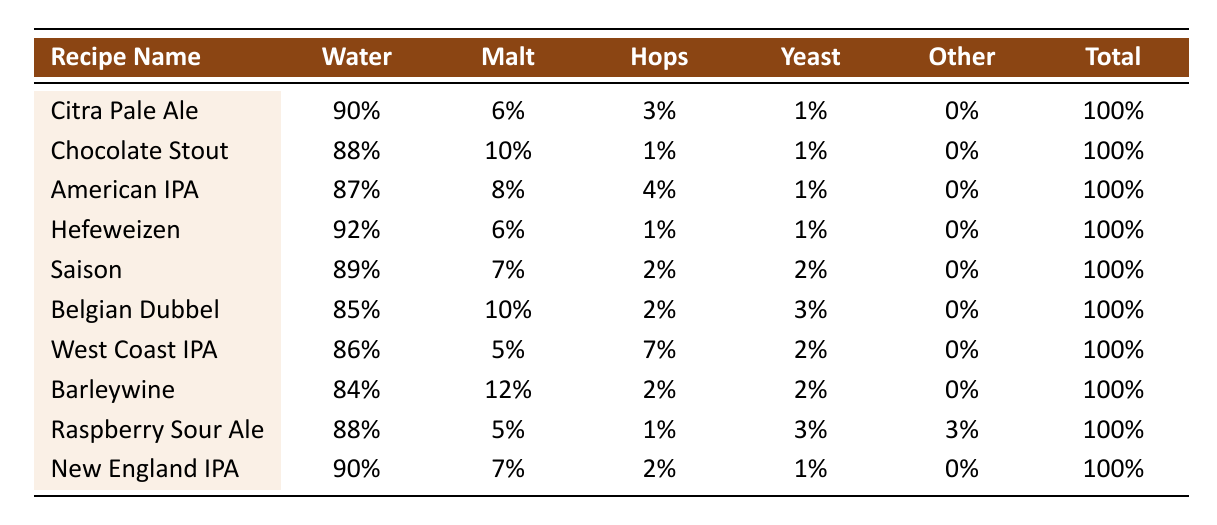What is the water percentage in the "Belgian Dubbel" recipe? The table shows that the water percentage in the "Belgian Dubbel" recipe is 85%
Answer: 85% Which recipe has the highest hops percentage? By reviewing the table, the "West Coast IPA" has the highest hops percentage at 7%.
Answer: West Coast IPA What is the average malt percentage of all the recipes? To find the average malt percentage: (6 + 10 + 8 + 6 + 7 + 10 + 5 + 12 + 5 + 7) = 76; there are 10 recipes, so 76/10 = 7.6.
Answer: 7.6% Does the "Raspberry Sour Ale" contain any "Other Ingredients"? The table indicates that the "Raspberry Sour Ale" does contain other ingredients, with a percentage of 3%.
Answer: Yes What is the total water percentage across all recipes? The total water percentage is the sum of all water percentages from each recipe: 90 + 88 + 87 + 92 + 89 + 85 + 86 + 84 + 88 + 90 = 900.
Answer: 900% Which recipe has the lowest malt percentage? By reviewing the table, the "West Coast IPA" has the lowest malt percentage at 5%.
Answer: West Coast IPA What is the difference in hops percentage between the "Citra Pale Ale" and "American IPA"? The hops percentage for "Citra Pale Ale" is 3% and for "American IPA" is 4%; therefore, the difference is 4 - 3 = 1%.
Answer: 1% If you combine the yeast percentages of "Saison" and "Belgian Dubbel," what would that be? The "Saison" has a yeast percentage of 2%, and the "Belgian Dubbel" has 3%. Adding these together: 2 + 3 = 5%.
Answer: 5% Which recipes have a water percentage greater than 90%? According to the table, the recipes with water percentages greater than 90% are "Hefeweizen" at 92% and "Citra Pale Ale" at 90%.
Answer: Hefeweizen, Citra Pale Ale How many recipes have a hops percentage of 1%? The table shows that there are three recipes with a hops percentage of 1%: "Chocolate Stout," "Hefeweizen," and "Raspberry Sour Ale."
Answer: 3 